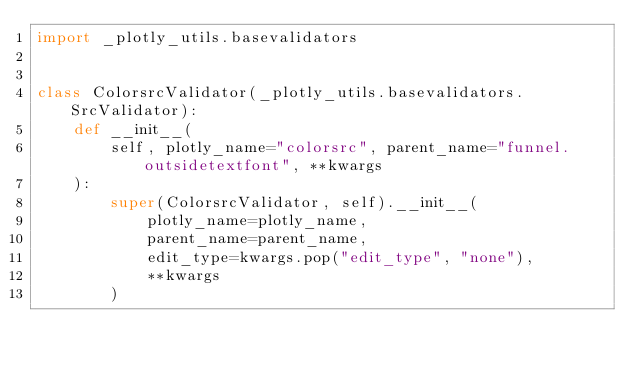Convert code to text. <code><loc_0><loc_0><loc_500><loc_500><_Python_>import _plotly_utils.basevalidators


class ColorsrcValidator(_plotly_utils.basevalidators.SrcValidator):
    def __init__(
        self, plotly_name="colorsrc", parent_name="funnel.outsidetextfont", **kwargs
    ):
        super(ColorsrcValidator, self).__init__(
            plotly_name=plotly_name,
            parent_name=parent_name,
            edit_type=kwargs.pop("edit_type", "none"),
            **kwargs
        )
</code> 